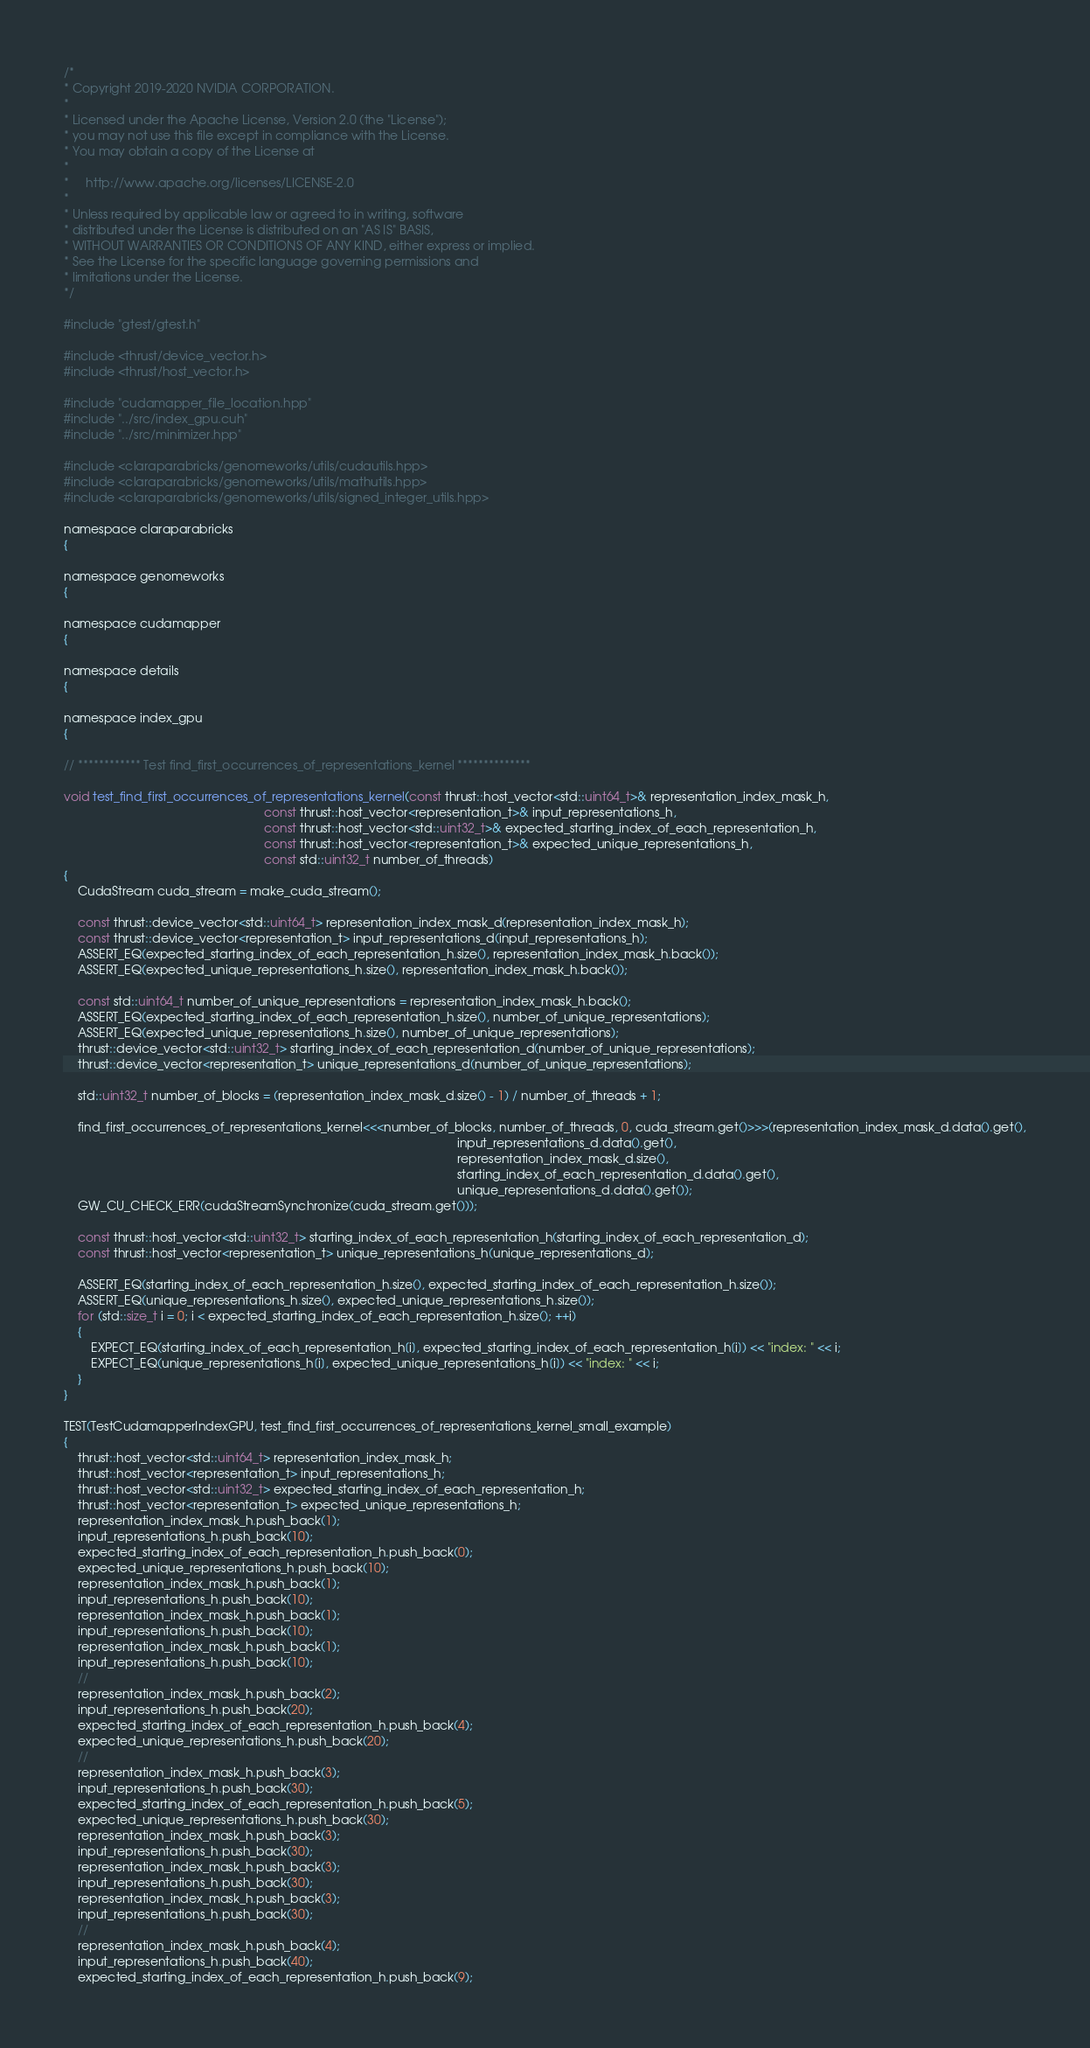<code> <loc_0><loc_0><loc_500><loc_500><_Cuda_>/*
* Copyright 2019-2020 NVIDIA CORPORATION.
*
* Licensed under the Apache License, Version 2.0 (the "License");
* you may not use this file except in compliance with the License.
* You may obtain a copy of the License at
*
*     http://www.apache.org/licenses/LICENSE-2.0
*
* Unless required by applicable law or agreed to in writing, software
* distributed under the License is distributed on an "AS IS" BASIS,
* WITHOUT WARRANTIES OR CONDITIONS OF ANY KIND, either express or implied.
* See the License for the specific language governing permissions and
* limitations under the License.
*/

#include "gtest/gtest.h"

#include <thrust/device_vector.h>
#include <thrust/host_vector.h>

#include "cudamapper_file_location.hpp"
#include "../src/index_gpu.cuh"
#include "../src/minimizer.hpp"

#include <claraparabricks/genomeworks/utils/cudautils.hpp>
#include <claraparabricks/genomeworks/utils/mathutils.hpp>
#include <claraparabricks/genomeworks/utils/signed_integer_utils.hpp>

namespace claraparabricks
{

namespace genomeworks
{

namespace cudamapper
{

namespace details
{

namespace index_gpu
{

// ************ Test find_first_occurrences_of_representations_kernel **************

void test_find_first_occurrences_of_representations_kernel(const thrust::host_vector<std::uint64_t>& representation_index_mask_h,
                                                           const thrust::host_vector<representation_t>& input_representations_h,
                                                           const thrust::host_vector<std::uint32_t>& expected_starting_index_of_each_representation_h,
                                                           const thrust::host_vector<representation_t>& expected_unique_representations_h,
                                                           const std::uint32_t number_of_threads)
{
    CudaStream cuda_stream = make_cuda_stream();

    const thrust::device_vector<std::uint64_t> representation_index_mask_d(representation_index_mask_h);
    const thrust::device_vector<representation_t> input_representations_d(input_representations_h);
    ASSERT_EQ(expected_starting_index_of_each_representation_h.size(), representation_index_mask_h.back());
    ASSERT_EQ(expected_unique_representations_h.size(), representation_index_mask_h.back());

    const std::uint64_t number_of_unique_representations = representation_index_mask_h.back();
    ASSERT_EQ(expected_starting_index_of_each_representation_h.size(), number_of_unique_representations);
    ASSERT_EQ(expected_unique_representations_h.size(), number_of_unique_representations);
    thrust::device_vector<std::uint32_t> starting_index_of_each_representation_d(number_of_unique_representations);
    thrust::device_vector<representation_t> unique_representations_d(number_of_unique_representations);

    std::uint32_t number_of_blocks = (representation_index_mask_d.size() - 1) / number_of_threads + 1;

    find_first_occurrences_of_representations_kernel<<<number_of_blocks, number_of_threads, 0, cuda_stream.get()>>>(representation_index_mask_d.data().get(),
                                                                                                                    input_representations_d.data().get(),
                                                                                                                    representation_index_mask_d.size(),
                                                                                                                    starting_index_of_each_representation_d.data().get(),
                                                                                                                    unique_representations_d.data().get());
    GW_CU_CHECK_ERR(cudaStreamSynchronize(cuda_stream.get()));

    const thrust::host_vector<std::uint32_t> starting_index_of_each_representation_h(starting_index_of_each_representation_d);
    const thrust::host_vector<representation_t> unique_representations_h(unique_representations_d);

    ASSERT_EQ(starting_index_of_each_representation_h.size(), expected_starting_index_of_each_representation_h.size());
    ASSERT_EQ(unique_representations_h.size(), expected_unique_representations_h.size());
    for (std::size_t i = 0; i < expected_starting_index_of_each_representation_h.size(); ++i)
    {
        EXPECT_EQ(starting_index_of_each_representation_h[i], expected_starting_index_of_each_representation_h[i]) << "index: " << i;
        EXPECT_EQ(unique_representations_h[i], expected_unique_representations_h[i]) << "index: " << i;
    }
}

TEST(TestCudamapperIndexGPU, test_find_first_occurrences_of_representations_kernel_small_example)
{
    thrust::host_vector<std::uint64_t> representation_index_mask_h;
    thrust::host_vector<representation_t> input_representations_h;
    thrust::host_vector<std::uint32_t> expected_starting_index_of_each_representation_h;
    thrust::host_vector<representation_t> expected_unique_representations_h;
    representation_index_mask_h.push_back(1);
    input_representations_h.push_back(10);
    expected_starting_index_of_each_representation_h.push_back(0);
    expected_unique_representations_h.push_back(10);
    representation_index_mask_h.push_back(1);
    input_representations_h.push_back(10);
    representation_index_mask_h.push_back(1);
    input_representations_h.push_back(10);
    representation_index_mask_h.push_back(1);
    input_representations_h.push_back(10);
    //
    representation_index_mask_h.push_back(2);
    input_representations_h.push_back(20);
    expected_starting_index_of_each_representation_h.push_back(4);
    expected_unique_representations_h.push_back(20);
    //
    representation_index_mask_h.push_back(3);
    input_representations_h.push_back(30);
    expected_starting_index_of_each_representation_h.push_back(5);
    expected_unique_representations_h.push_back(30);
    representation_index_mask_h.push_back(3);
    input_representations_h.push_back(30);
    representation_index_mask_h.push_back(3);
    input_representations_h.push_back(30);
    representation_index_mask_h.push_back(3);
    input_representations_h.push_back(30);
    //
    representation_index_mask_h.push_back(4);
    input_representations_h.push_back(40);
    expected_starting_index_of_each_representation_h.push_back(9);</code> 